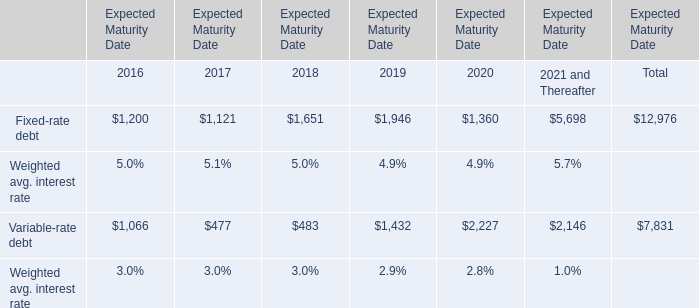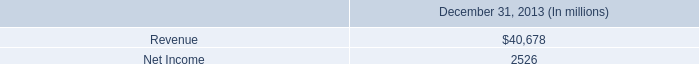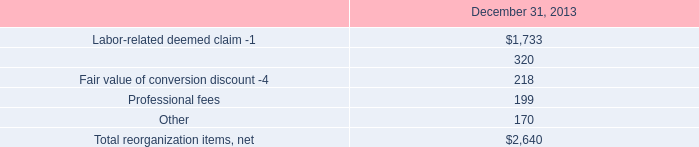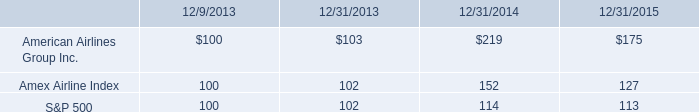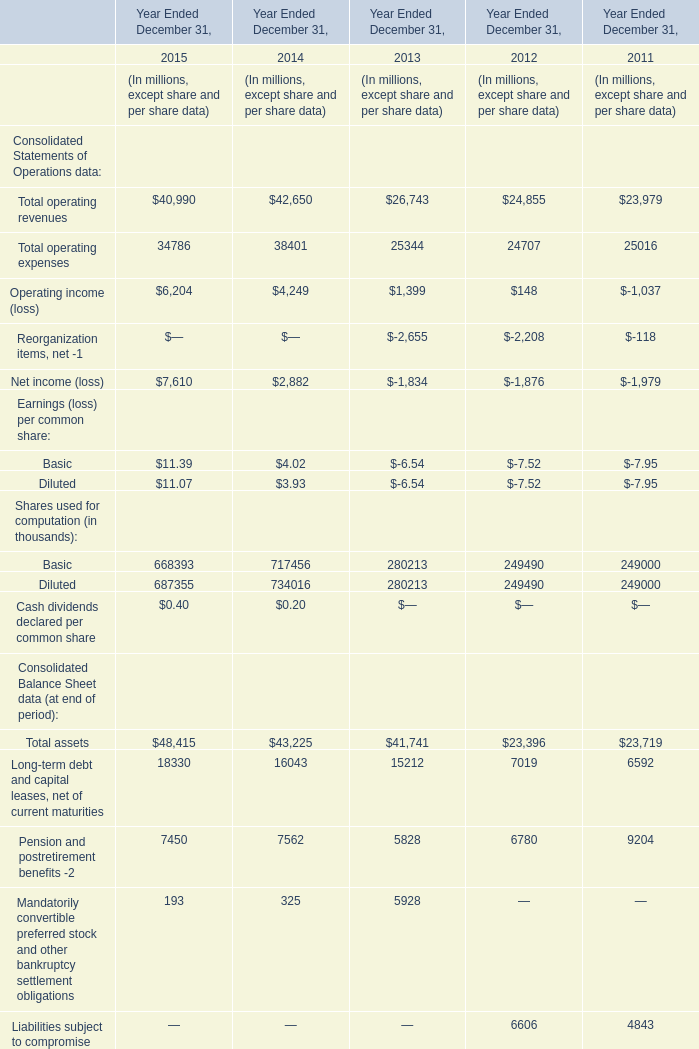What's the total amount of the Total operating expenses in the years where Total operating revenues is greater than 42000? (in million) 
Answer: 34786. 